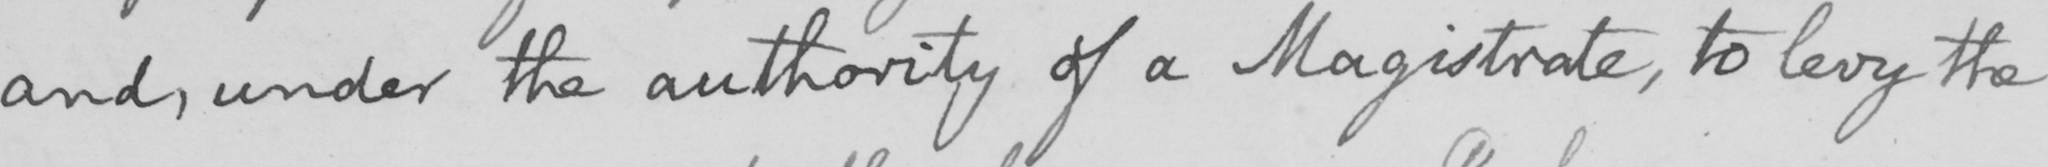What text is written in this handwritten line? and , under the authority of a Magistrate , to levy the 